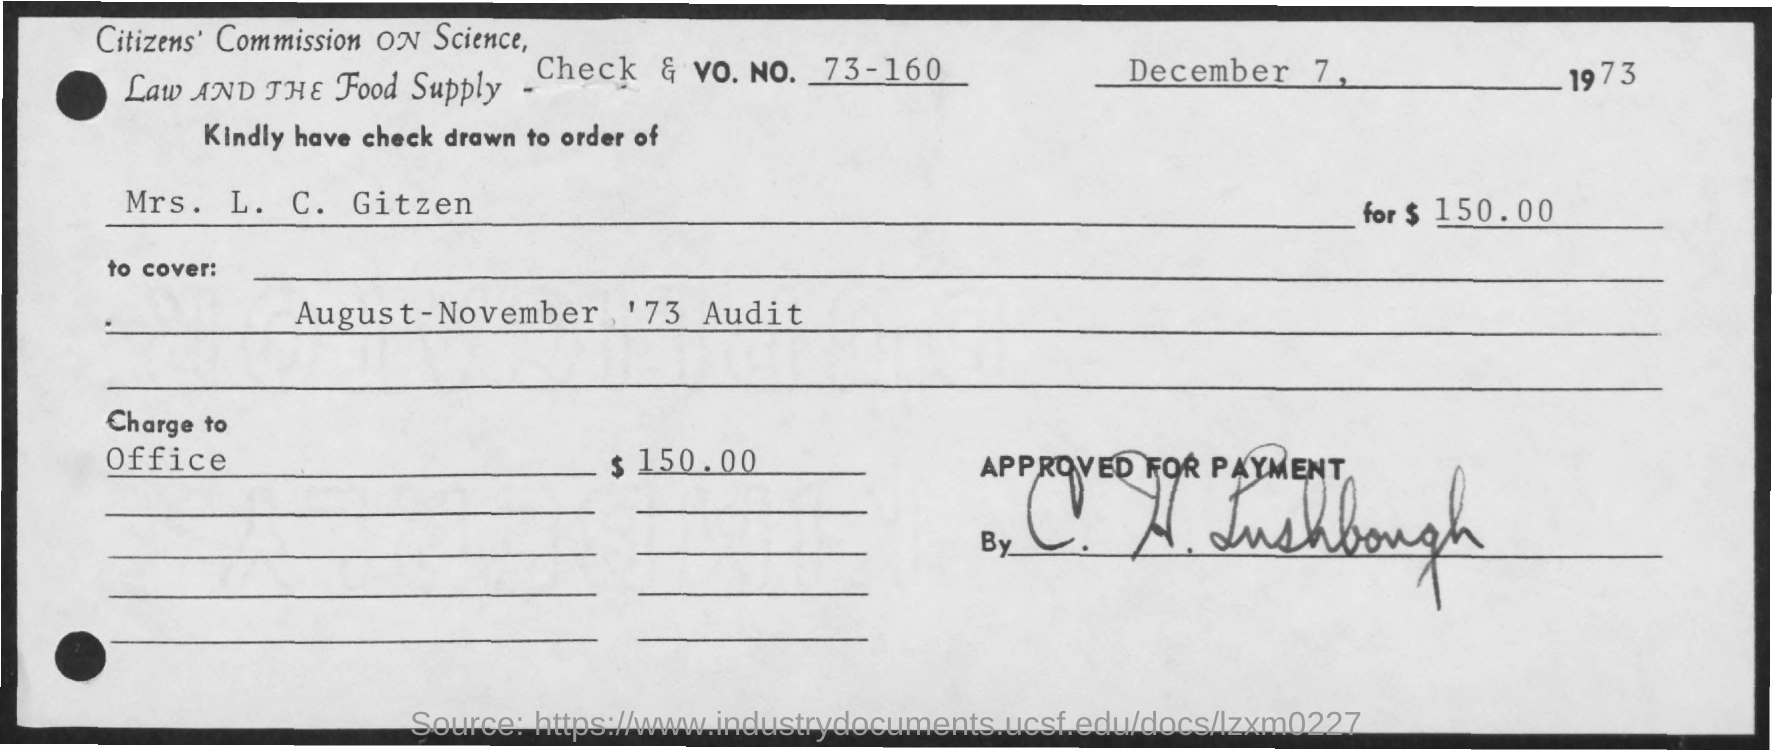Mention a couple of crucial points in this snapshot. The check and vo.no. mentioned are 73-160. The date mentioned in the given page is December 7, 1973. The amount mentioned is $150.00. The check is made out to the order of Mrs. L.C. Gitzen. 